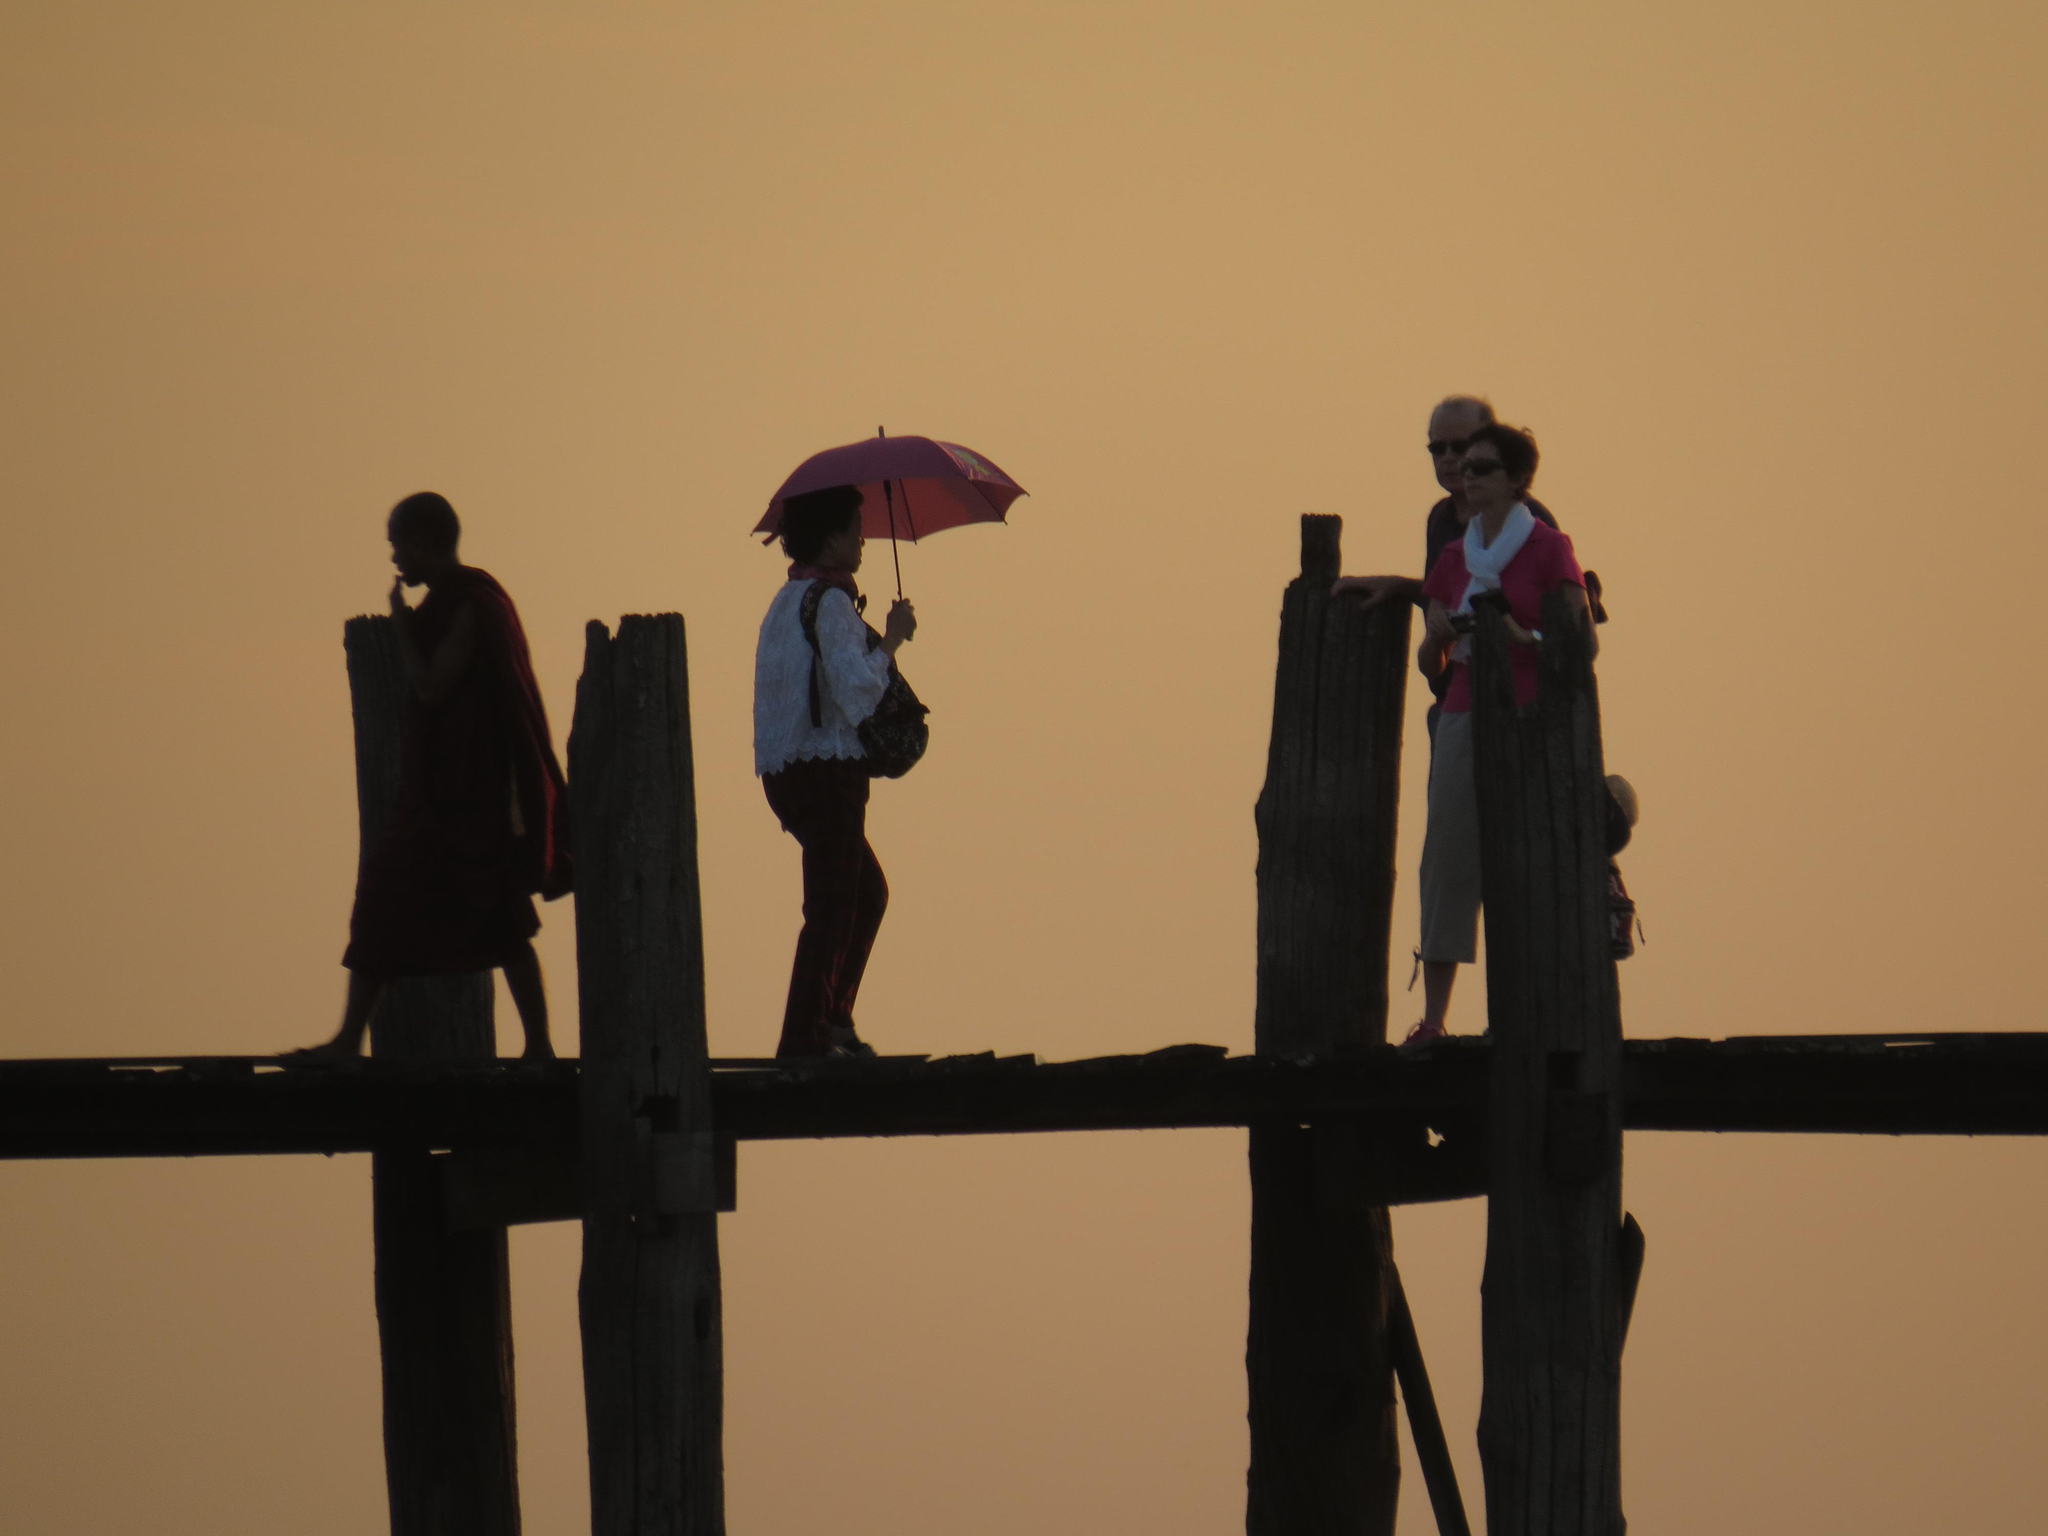What type of structure is present in the image? There is a wooden bridge in the image. Who is on the bridge in the image? Two men and two women are walking on the bridge. What can be seen in the background of the image? There is a sky visible in the background of the image. What type of toys are scattered on the bridge in the image? There are no toys present on the bridge in the image. 